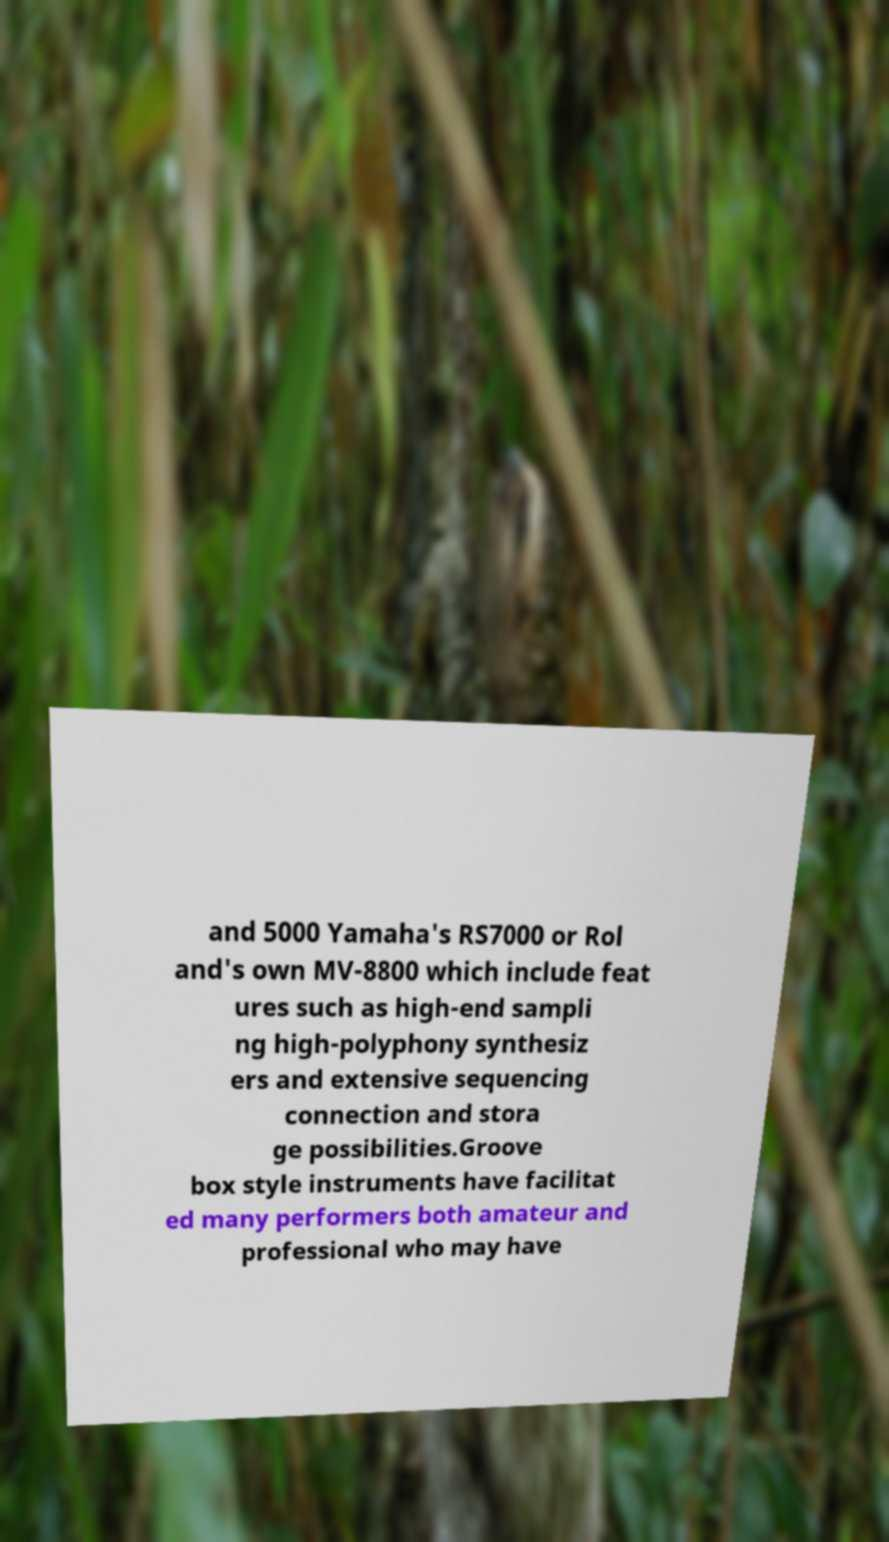There's text embedded in this image that I need extracted. Can you transcribe it verbatim? and 5000 Yamaha's RS7000 or Rol and's own MV-8800 which include feat ures such as high-end sampli ng high-polyphony synthesiz ers and extensive sequencing connection and stora ge possibilities.Groove box style instruments have facilitat ed many performers both amateur and professional who may have 